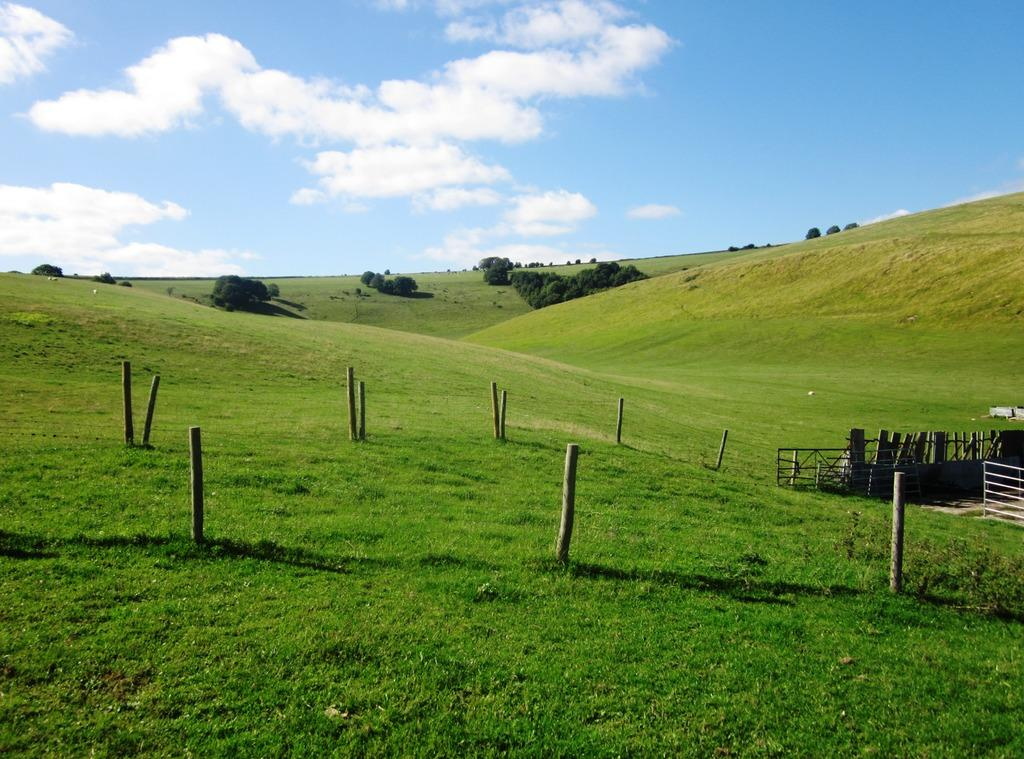What type of landscape is depicted in the image? There is a grassland in the image. What structures can be seen in the grassland? There are wooden poles and fencing in the image. What can be seen in the distance in the image? There are trees and the sky visible in the background of the image. How many dimes are scattered on the grassland in the image? There are no dimes present in the image; it features a grassland with wooden poles, fencing, trees, and the sky. Can you see a girl or a grandmother in the image? There is no girl or grandmother depicted in the image. 